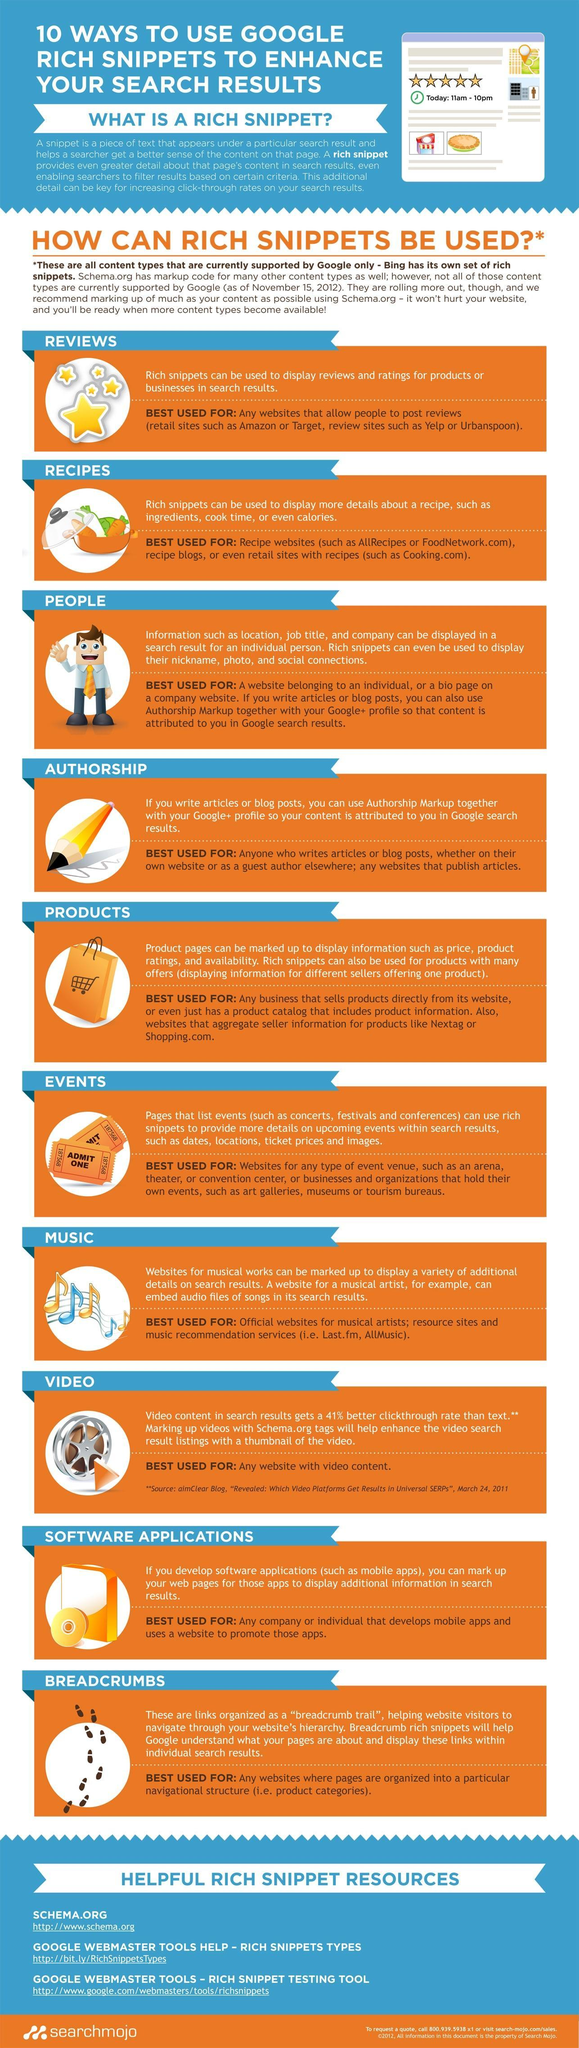what is the second one in the list of helpful rich snippet resources?
Answer the question with a short phrase. google webmaster tools help - rich snippets types What is the second use of rich snippets given in this infographic? recipes what is the website link given along with first helpful rich snippet resource? http://www.schema.org What is the sixth use of rich snippets given in this infographic? events What is the fifth use of rich snippets given in this infographic? products What is the use of rich snippets given second last in the list? software applications what is the third one in the list of helpful rich snippet resources? google webmaster tools help - rich snippet testing tool What is the third use of rich snippets given in this infographic? people how many helpful rich snippet resources are given in this infographic? 3 how many uses of rich snippets are given in this infographic? 10 